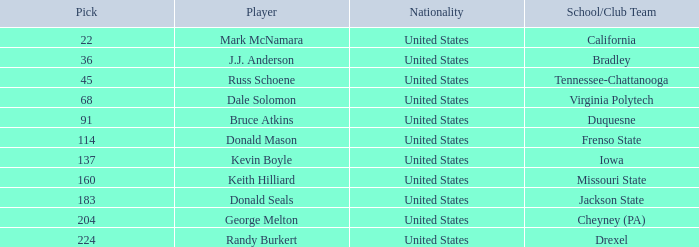What is the nationality of the player from Drexel who had a pick larger than 183? United States. 